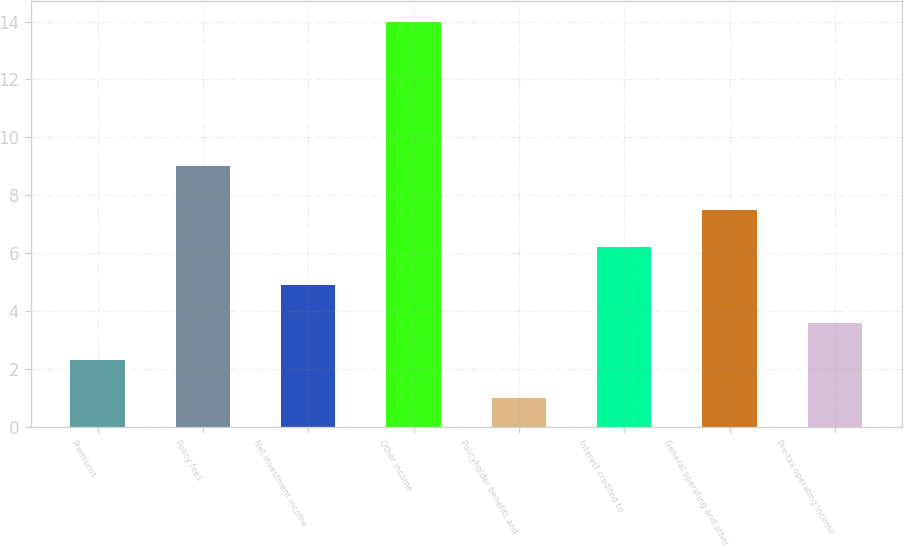<chart> <loc_0><loc_0><loc_500><loc_500><bar_chart><fcel>Premiums<fcel>Policy fees<fcel>Net investment income<fcel>Other income<fcel>Policyholder benefits and<fcel>Interest credited to<fcel>General operating and other<fcel>Pre-tax operating income<nl><fcel>2.3<fcel>9<fcel>4.9<fcel>14<fcel>1<fcel>6.2<fcel>7.5<fcel>3.6<nl></chart> 